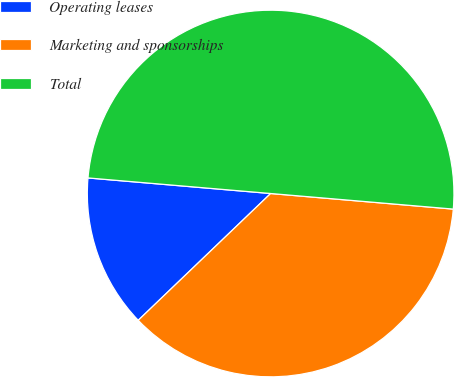<chart> <loc_0><loc_0><loc_500><loc_500><pie_chart><fcel>Operating leases<fcel>Marketing and sponsorships<fcel>Total<nl><fcel>13.51%<fcel>36.49%<fcel>50.0%<nl></chart> 